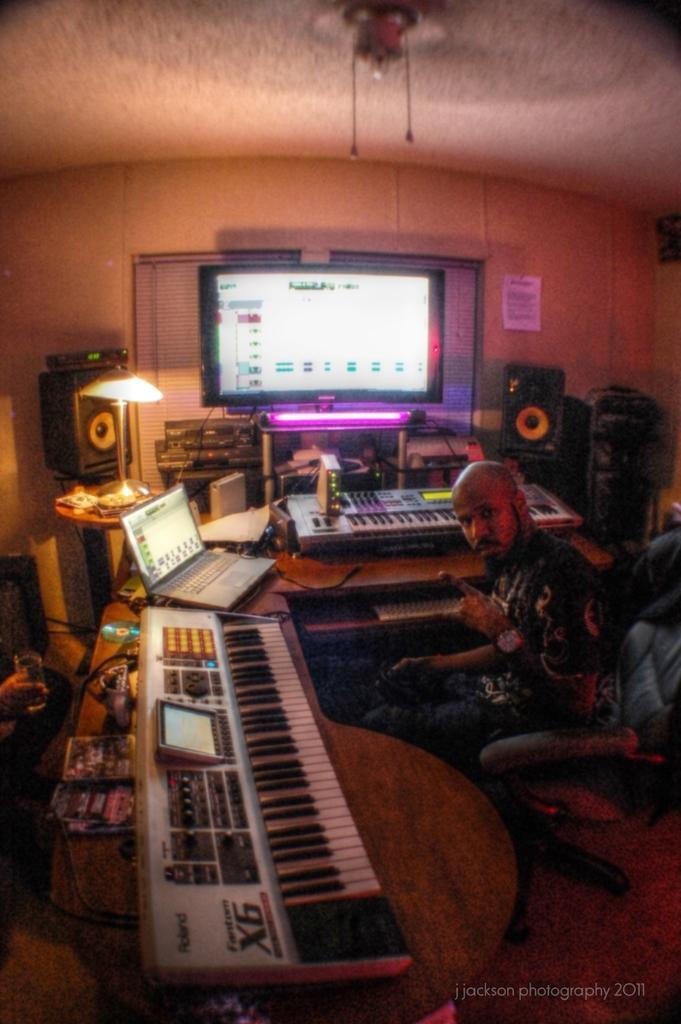Describe this image in one or two sentences. In this picture we can see few people are seated on the chair in the room in front of them we can see key board, laptop, monitor, light and sound system. 